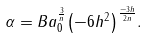Convert formula to latex. <formula><loc_0><loc_0><loc_500><loc_500>\alpha = B a _ { 0 } ^ { \frac { 3 } { n } } { \left ( - 6 h ^ { 2 } \right ) } ^ { \frac { - 3 h } { 2 n } } .</formula> 